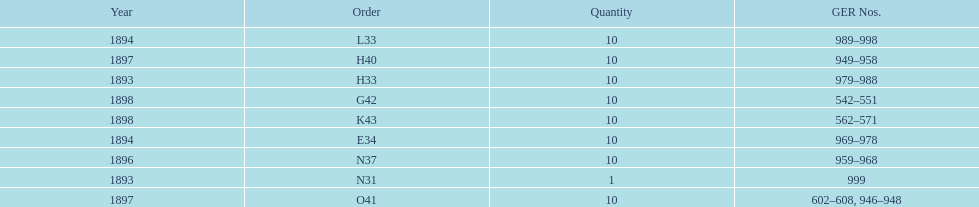What amount of time to the years span? 5 years. 